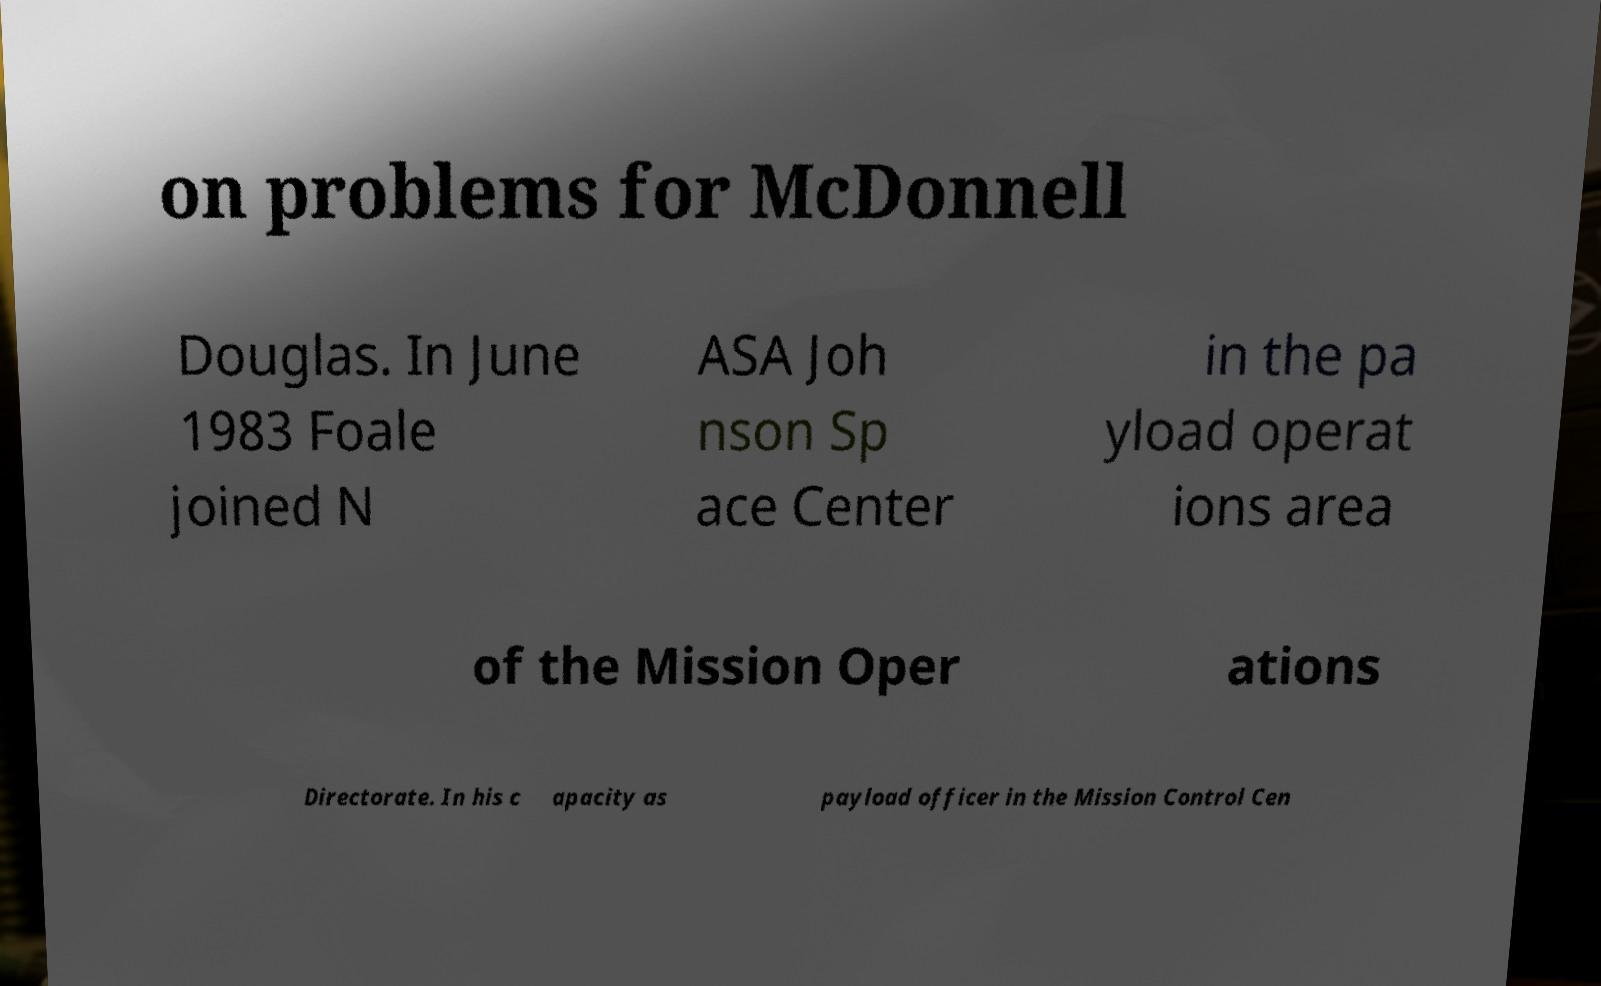Please read and relay the text visible in this image. What does it say? on problems for McDonnell Douglas. In June 1983 Foale joined N ASA Joh nson Sp ace Center in the pa yload operat ions area of the Mission Oper ations Directorate. In his c apacity as payload officer in the Mission Control Cen 